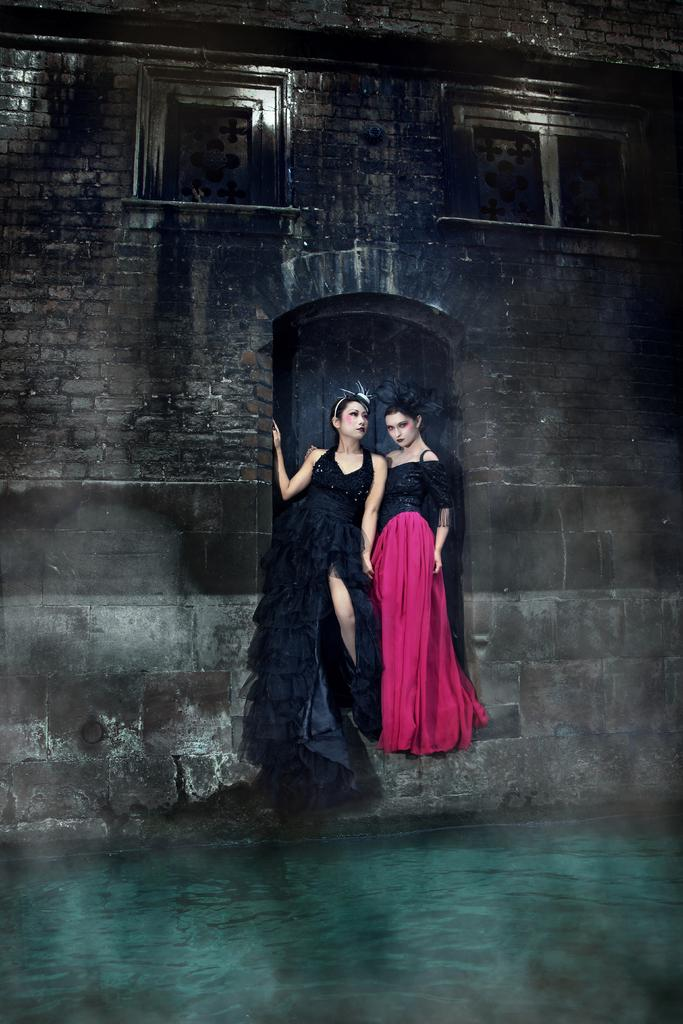What is at the bottom of the image? There is water at the bottom of the image. What can be seen in the middle of the image? Two women are standing in the middle of the image. What is behind the women? There is a wall behind the women. How many ants can be seen crawling on the wall behind the women? There are no ants visible in the image; only the two women and the wall are present. What type of bear is standing next to the women in the image? There is no bear present in the image; only the two women and the wall are visible. 